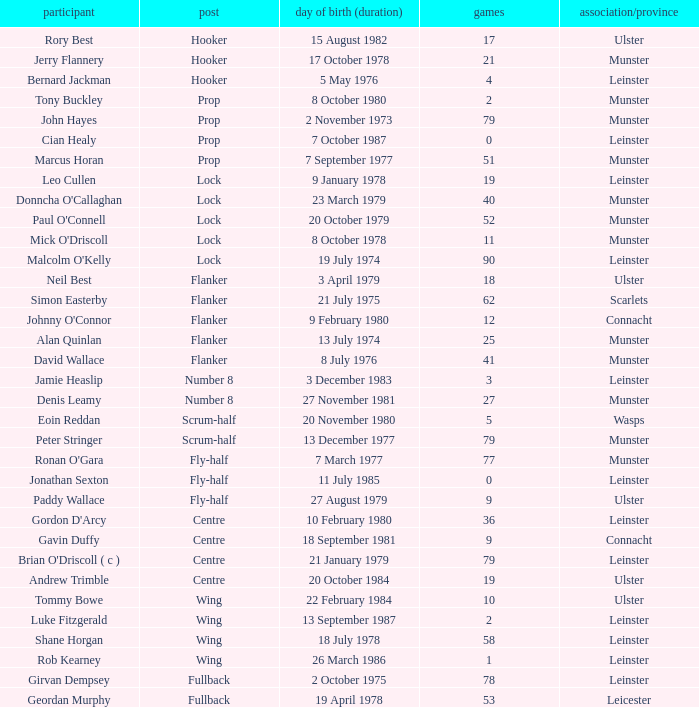How many Caps does the Club/province Munster, position of lock and Mick O'Driscoll have? 1.0. 